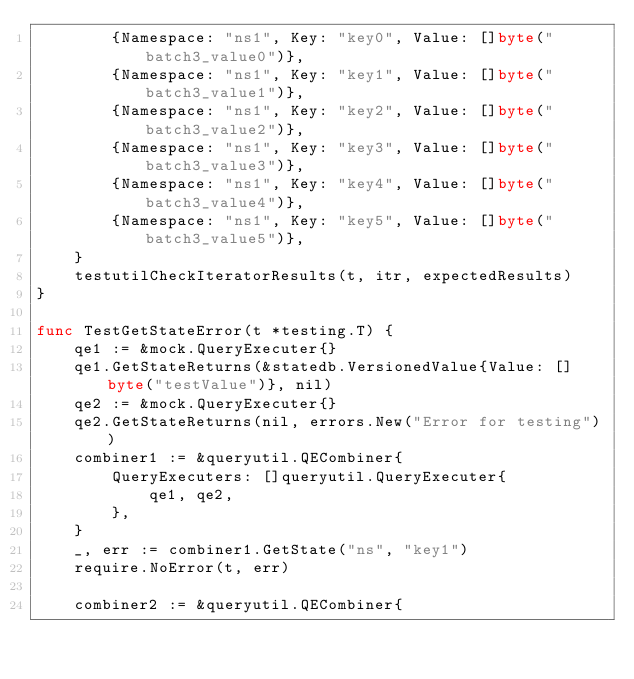<code> <loc_0><loc_0><loc_500><loc_500><_Go_>		{Namespace: "ns1", Key: "key0", Value: []byte("batch3_value0")},
		{Namespace: "ns1", Key: "key1", Value: []byte("batch3_value1")},
		{Namespace: "ns1", Key: "key2", Value: []byte("batch3_value2")},
		{Namespace: "ns1", Key: "key3", Value: []byte("batch3_value3")},
		{Namespace: "ns1", Key: "key4", Value: []byte("batch3_value4")},
		{Namespace: "ns1", Key: "key5", Value: []byte("batch3_value5")},
	}
	testutilCheckIteratorResults(t, itr, expectedResults)
}

func TestGetStateError(t *testing.T) {
	qe1 := &mock.QueryExecuter{}
	qe1.GetStateReturns(&statedb.VersionedValue{Value: []byte("testValue")}, nil)
	qe2 := &mock.QueryExecuter{}
	qe2.GetStateReturns(nil, errors.New("Error for testing"))
	combiner1 := &queryutil.QECombiner{
		QueryExecuters: []queryutil.QueryExecuter{
			qe1, qe2,
		},
	}
	_, err := combiner1.GetState("ns", "key1")
	require.NoError(t, err)

	combiner2 := &queryutil.QECombiner{</code> 